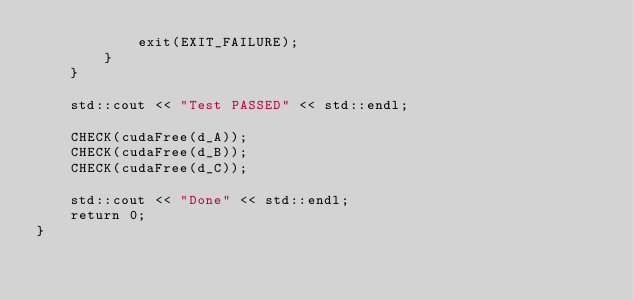Convert code to text. <code><loc_0><loc_0><loc_500><loc_500><_Cuda_>            exit(EXIT_FAILURE);
        }
    }

    std::cout << "Test PASSED" << std::endl;

    CHECK(cudaFree(d_A));
    CHECK(cudaFree(d_B));
    CHECK(cudaFree(d_C));

    std::cout << "Done" << std::endl;
    return 0;
}
</code> 